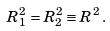<formula> <loc_0><loc_0><loc_500><loc_500>R _ { 1 } ^ { 2 } = R _ { 2 } ^ { 2 } \equiv R ^ { 2 } \, .</formula> 